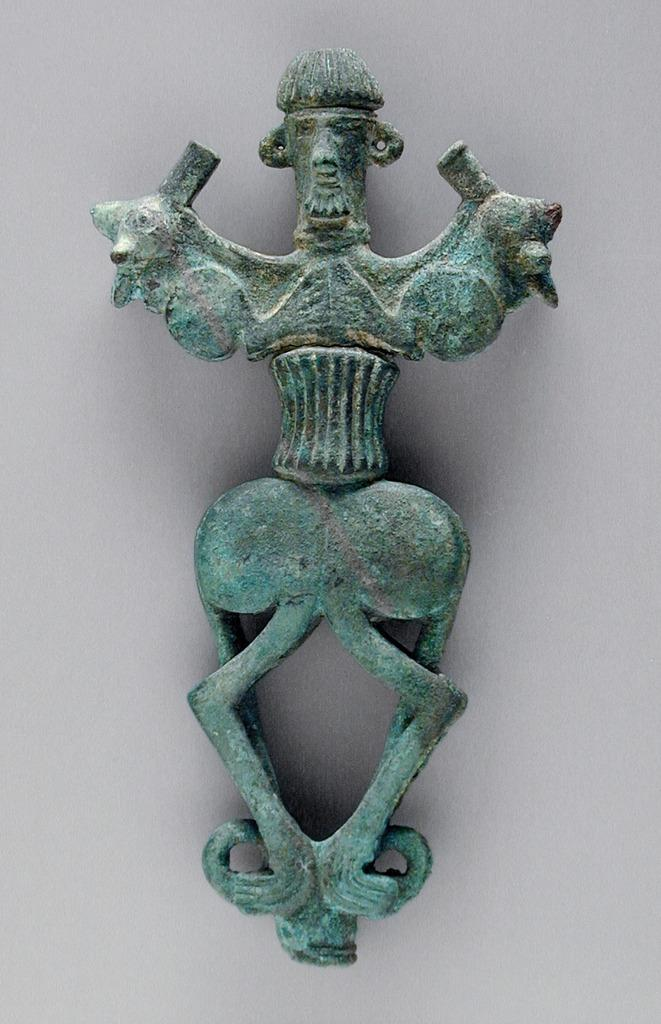What is the main object in the image? There is a bronze standard finial in the image. What is the material of the main object? The bronze standard finial is made of bronze. Where is the bronze standard finial attached? The bronze standard finial is attached to a white wall. What arithmetic operation is being performed by the sky in the image? The sky is not performing any arithmetic operation in the image, as it is a natural element and not capable of performing mathematical calculations. 